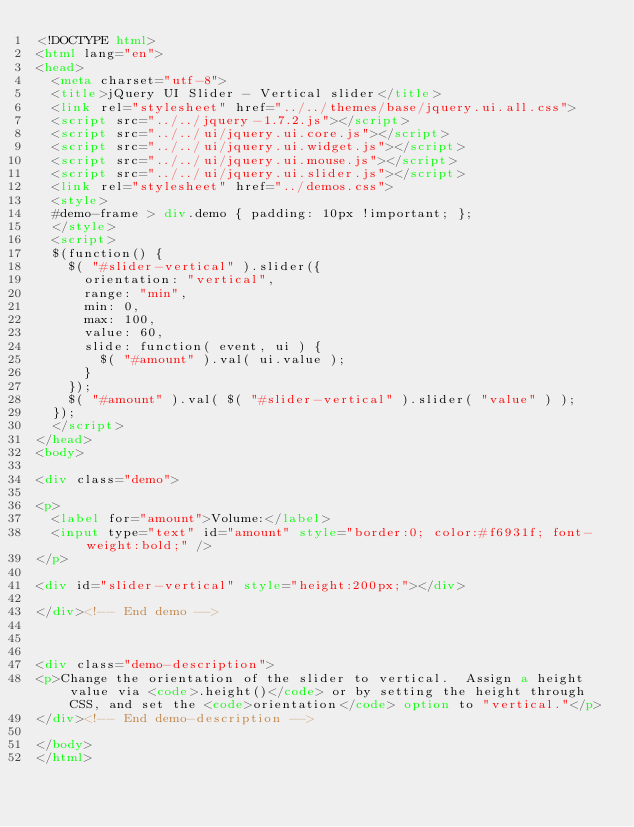<code> <loc_0><loc_0><loc_500><loc_500><_HTML_><!DOCTYPE html>
<html lang="en">
<head>
	<meta charset="utf-8">
	<title>jQuery UI Slider - Vertical slider</title>
	<link rel="stylesheet" href="../../themes/base/jquery.ui.all.css">
	<script src="../../jquery-1.7.2.js"></script>
	<script src="../../ui/jquery.ui.core.js"></script>
	<script src="../../ui/jquery.ui.widget.js"></script>
	<script src="../../ui/jquery.ui.mouse.js"></script>
	<script src="../../ui/jquery.ui.slider.js"></script>
	<link rel="stylesheet" href="../demos.css">
	<style>
	#demo-frame > div.demo { padding: 10px !important; };
	</style>
	<script>
	$(function() {
		$( "#slider-vertical" ).slider({
			orientation: "vertical",
			range: "min",
			min: 0,
			max: 100,
			value: 60,
			slide: function( event, ui ) {
				$( "#amount" ).val( ui.value );
			}
		});
		$( "#amount" ).val( $( "#slider-vertical" ).slider( "value" ) );
	});
	</script>
</head>
<body>

<div class="demo">

<p>
	<label for="amount">Volume:</label>
	<input type="text" id="amount" style="border:0; color:#f6931f; font-weight:bold;" />
</p>

<div id="slider-vertical" style="height:200px;"></div>

</div><!-- End demo -->



<div class="demo-description">
<p>Change the orientation of the slider to vertical.  Assign a height value via <code>.height()</code> or by setting the height through CSS, and set the <code>orientation</code> option to "vertical."</p>
</div><!-- End demo-description -->

</body>
</html>
</code> 